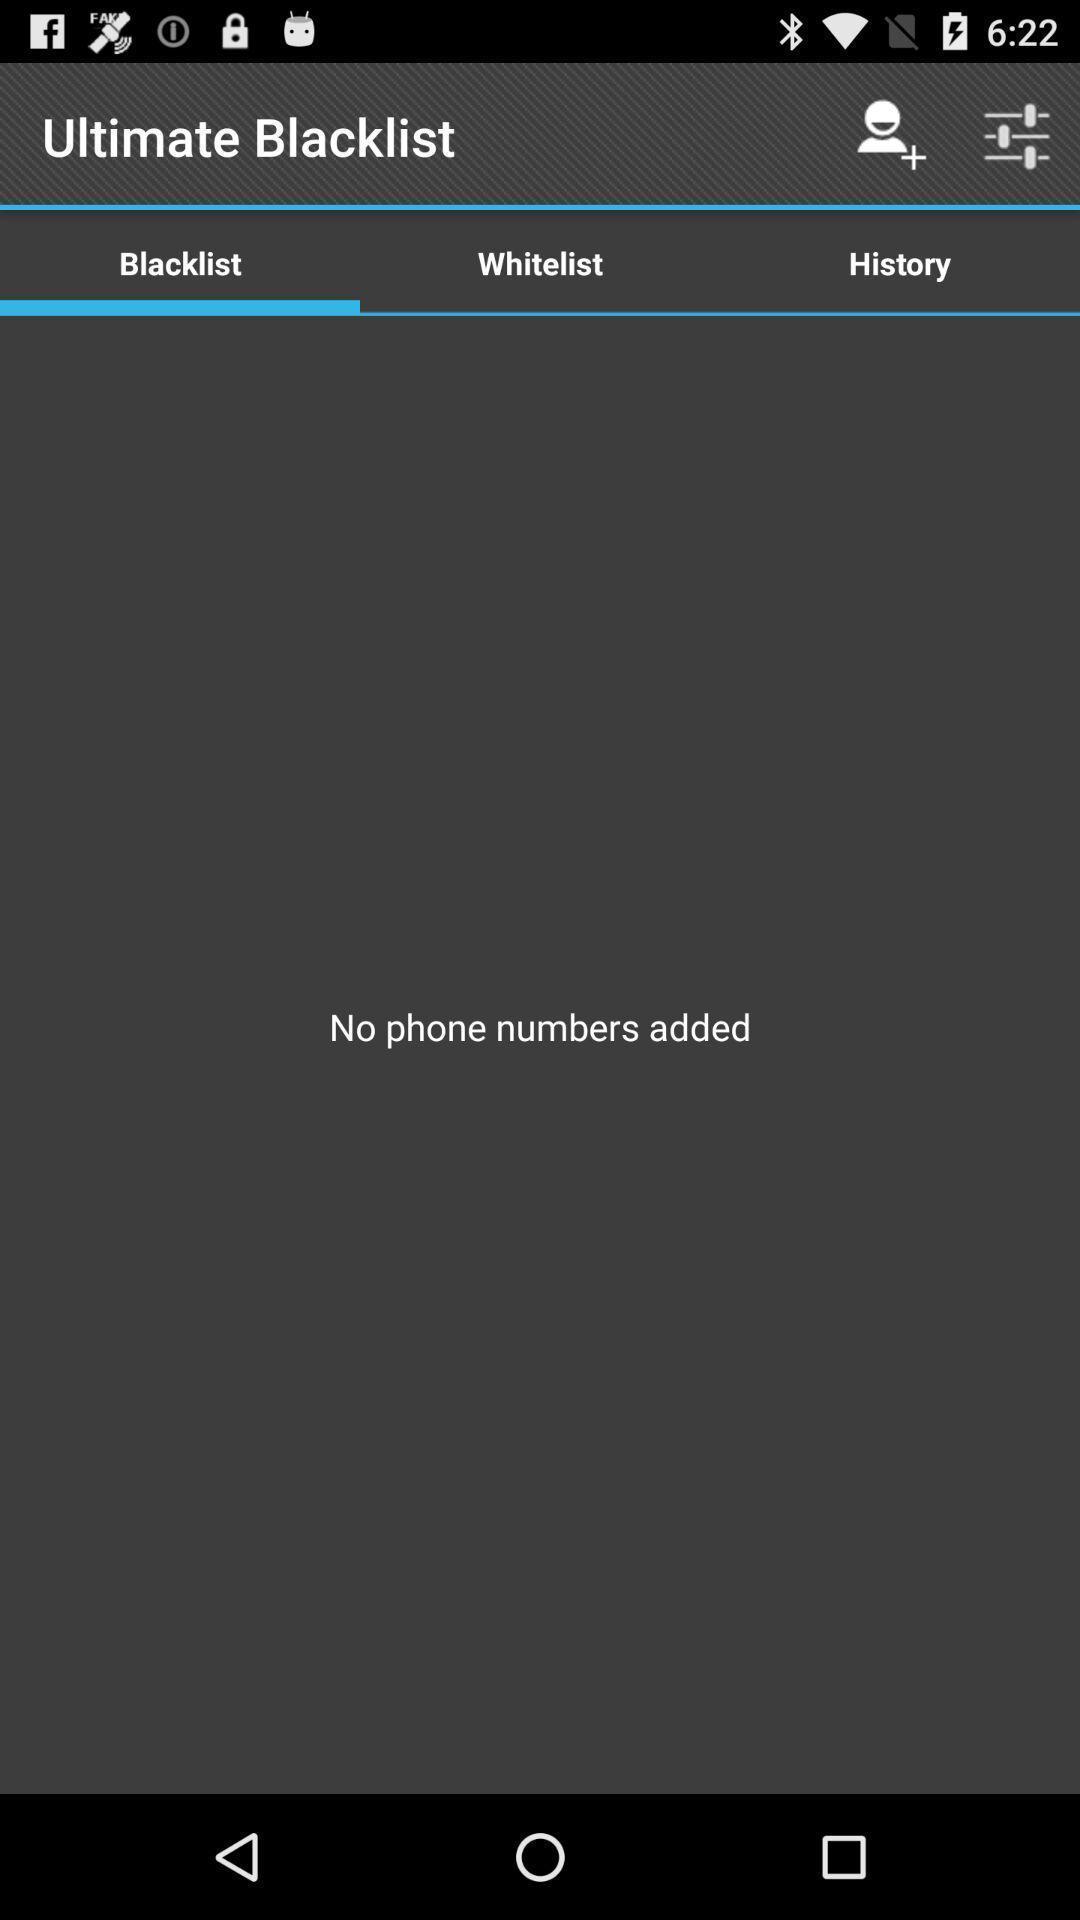Describe the visual elements of this screenshot. Page showing blacklist as empty. 